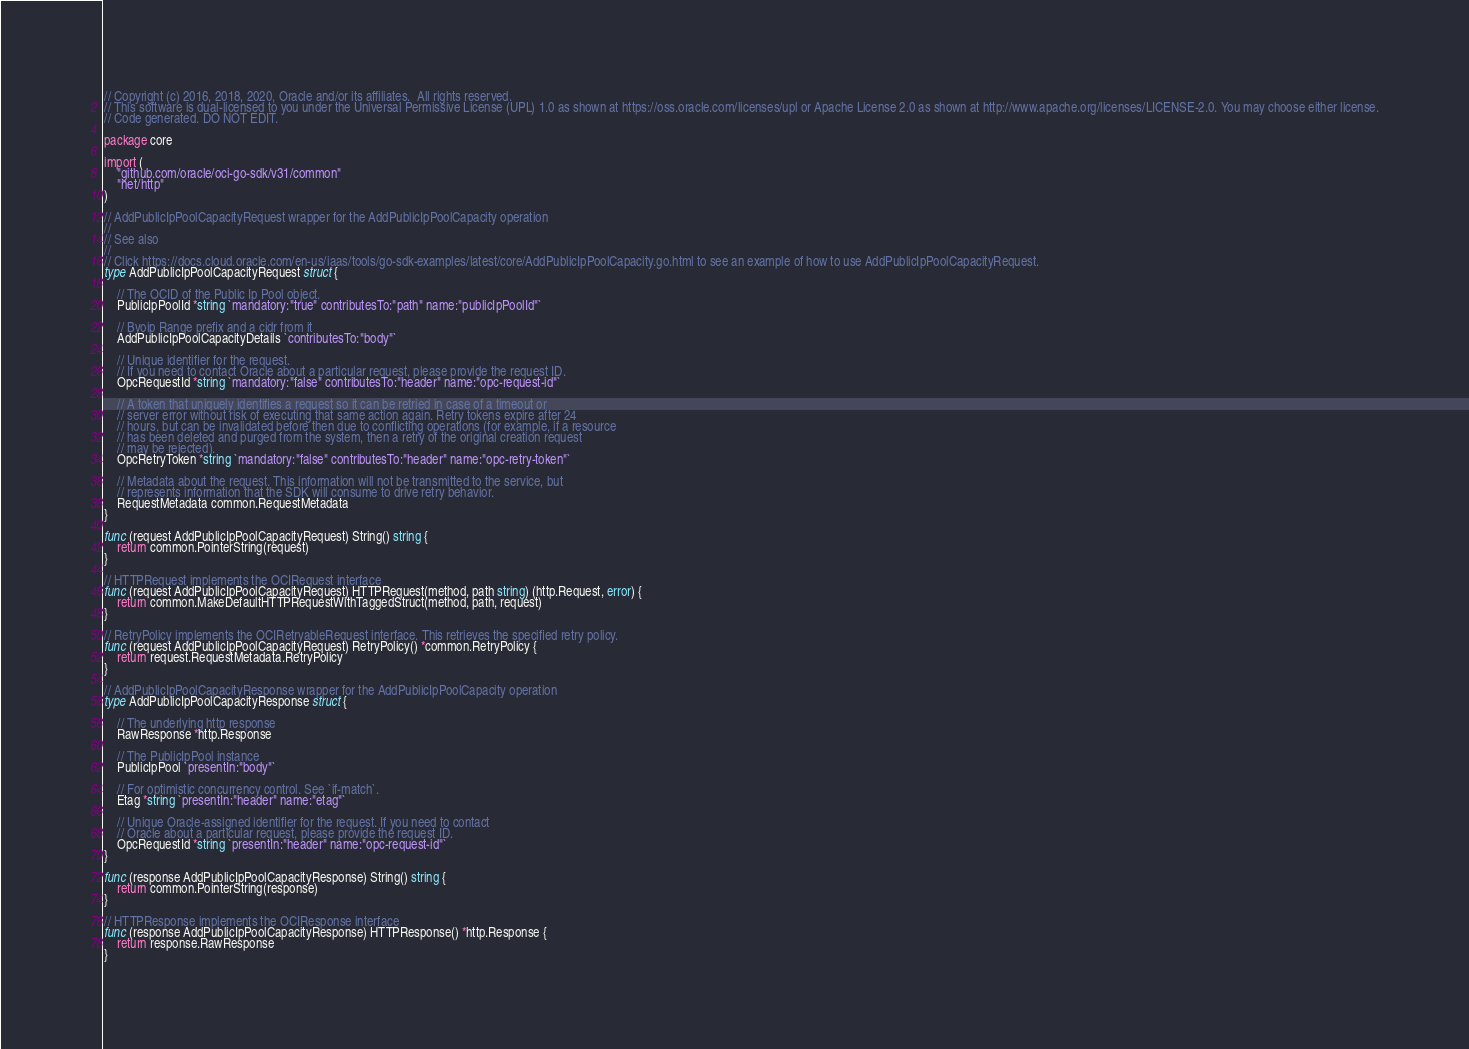Convert code to text. <code><loc_0><loc_0><loc_500><loc_500><_Go_>// Copyright (c) 2016, 2018, 2020, Oracle and/or its affiliates.  All rights reserved.
// This software is dual-licensed to you under the Universal Permissive License (UPL) 1.0 as shown at https://oss.oracle.com/licenses/upl or Apache License 2.0 as shown at http://www.apache.org/licenses/LICENSE-2.0. You may choose either license.
// Code generated. DO NOT EDIT.

package core

import (
	"github.com/oracle/oci-go-sdk/v31/common"
	"net/http"
)

// AddPublicIpPoolCapacityRequest wrapper for the AddPublicIpPoolCapacity operation
//
// See also
//
// Click https://docs.cloud.oracle.com/en-us/iaas/tools/go-sdk-examples/latest/core/AddPublicIpPoolCapacity.go.html to see an example of how to use AddPublicIpPoolCapacityRequest.
type AddPublicIpPoolCapacityRequest struct {

	// The OCID of the Public Ip Pool object.
	PublicIpPoolId *string `mandatory:"true" contributesTo:"path" name:"publicIpPoolId"`

	// Byoip Range prefix and a cidr from it
	AddPublicIpPoolCapacityDetails `contributesTo:"body"`

	// Unique identifier for the request.
	// If you need to contact Oracle about a particular request, please provide the request ID.
	OpcRequestId *string `mandatory:"false" contributesTo:"header" name:"opc-request-id"`

	// A token that uniquely identifies a request so it can be retried in case of a timeout or
	// server error without risk of executing that same action again. Retry tokens expire after 24
	// hours, but can be invalidated before then due to conflicting operations (for example, if a resource
	// has been deleted and purged from the system, then a retry of the original creation request
	// may be rejected).
	OpcRetryToken *string `mandatory:"false" contributesTo:"header" name:"opc-retry-token"`

	// Metadata about the request. This information will not be transmitted to the service, but
	// represents information that the SDK will consume to drive retry behavior.
	RequestMetadata common.RequestMetadata
}

func (request AddPublicIpPoolCapacityRequest) String() string {
	return common.PointerString(request)
}

// HTTPRequest implements the OCIRequest interface
func (request AddPublicIpPoolCapacityRequest) HTTPRequest(method, path string) (http.Request, error) {
	return common.MakeDefaultHTTPRequestWithTaggedStruct(method, path, request)
}

// RetryPolicy implements the OCIRetryableRequest interface. This retrieves the specified retry policy.
func (request AddPublicIpPoolCapacityRequest) RetryPolicy() *common.RetryPolicy {
	return request.RequestMetadata.RetryPolicy
}

// AddPublicIpPoolCapacityResponse wrapper for the AddPublicIpPoolCapacity operation
type AddPublicIpPoolCapacityResponse struct {

	// The underlying http response
	RawResponse *http.Response

	// The PublicIpPool instance
	PublicIpPool `presentIn:"body"`

	// For optimistic concurrency control. See `if-match`.
	Etag *string `presentIn:"header" name:"etag"`

	// Unique Oracle-assigned identifier for the request. If you need to contact
	// Oracle about a particular request, please provide the request ID.
	OpcRequestId *string `presentIn:"header" name:"opc-request-id"`
}

func (response AddPublicIpPoolCapacityResponse) String() string {
	return common.PointerString(response)
}

// HTTPResponse implements the OCIResponse interface
func (response AddPublicIpPoolCapacityResponse) HTTPResponse() *http.Response {
	return response.RawResponse
}
</code> 